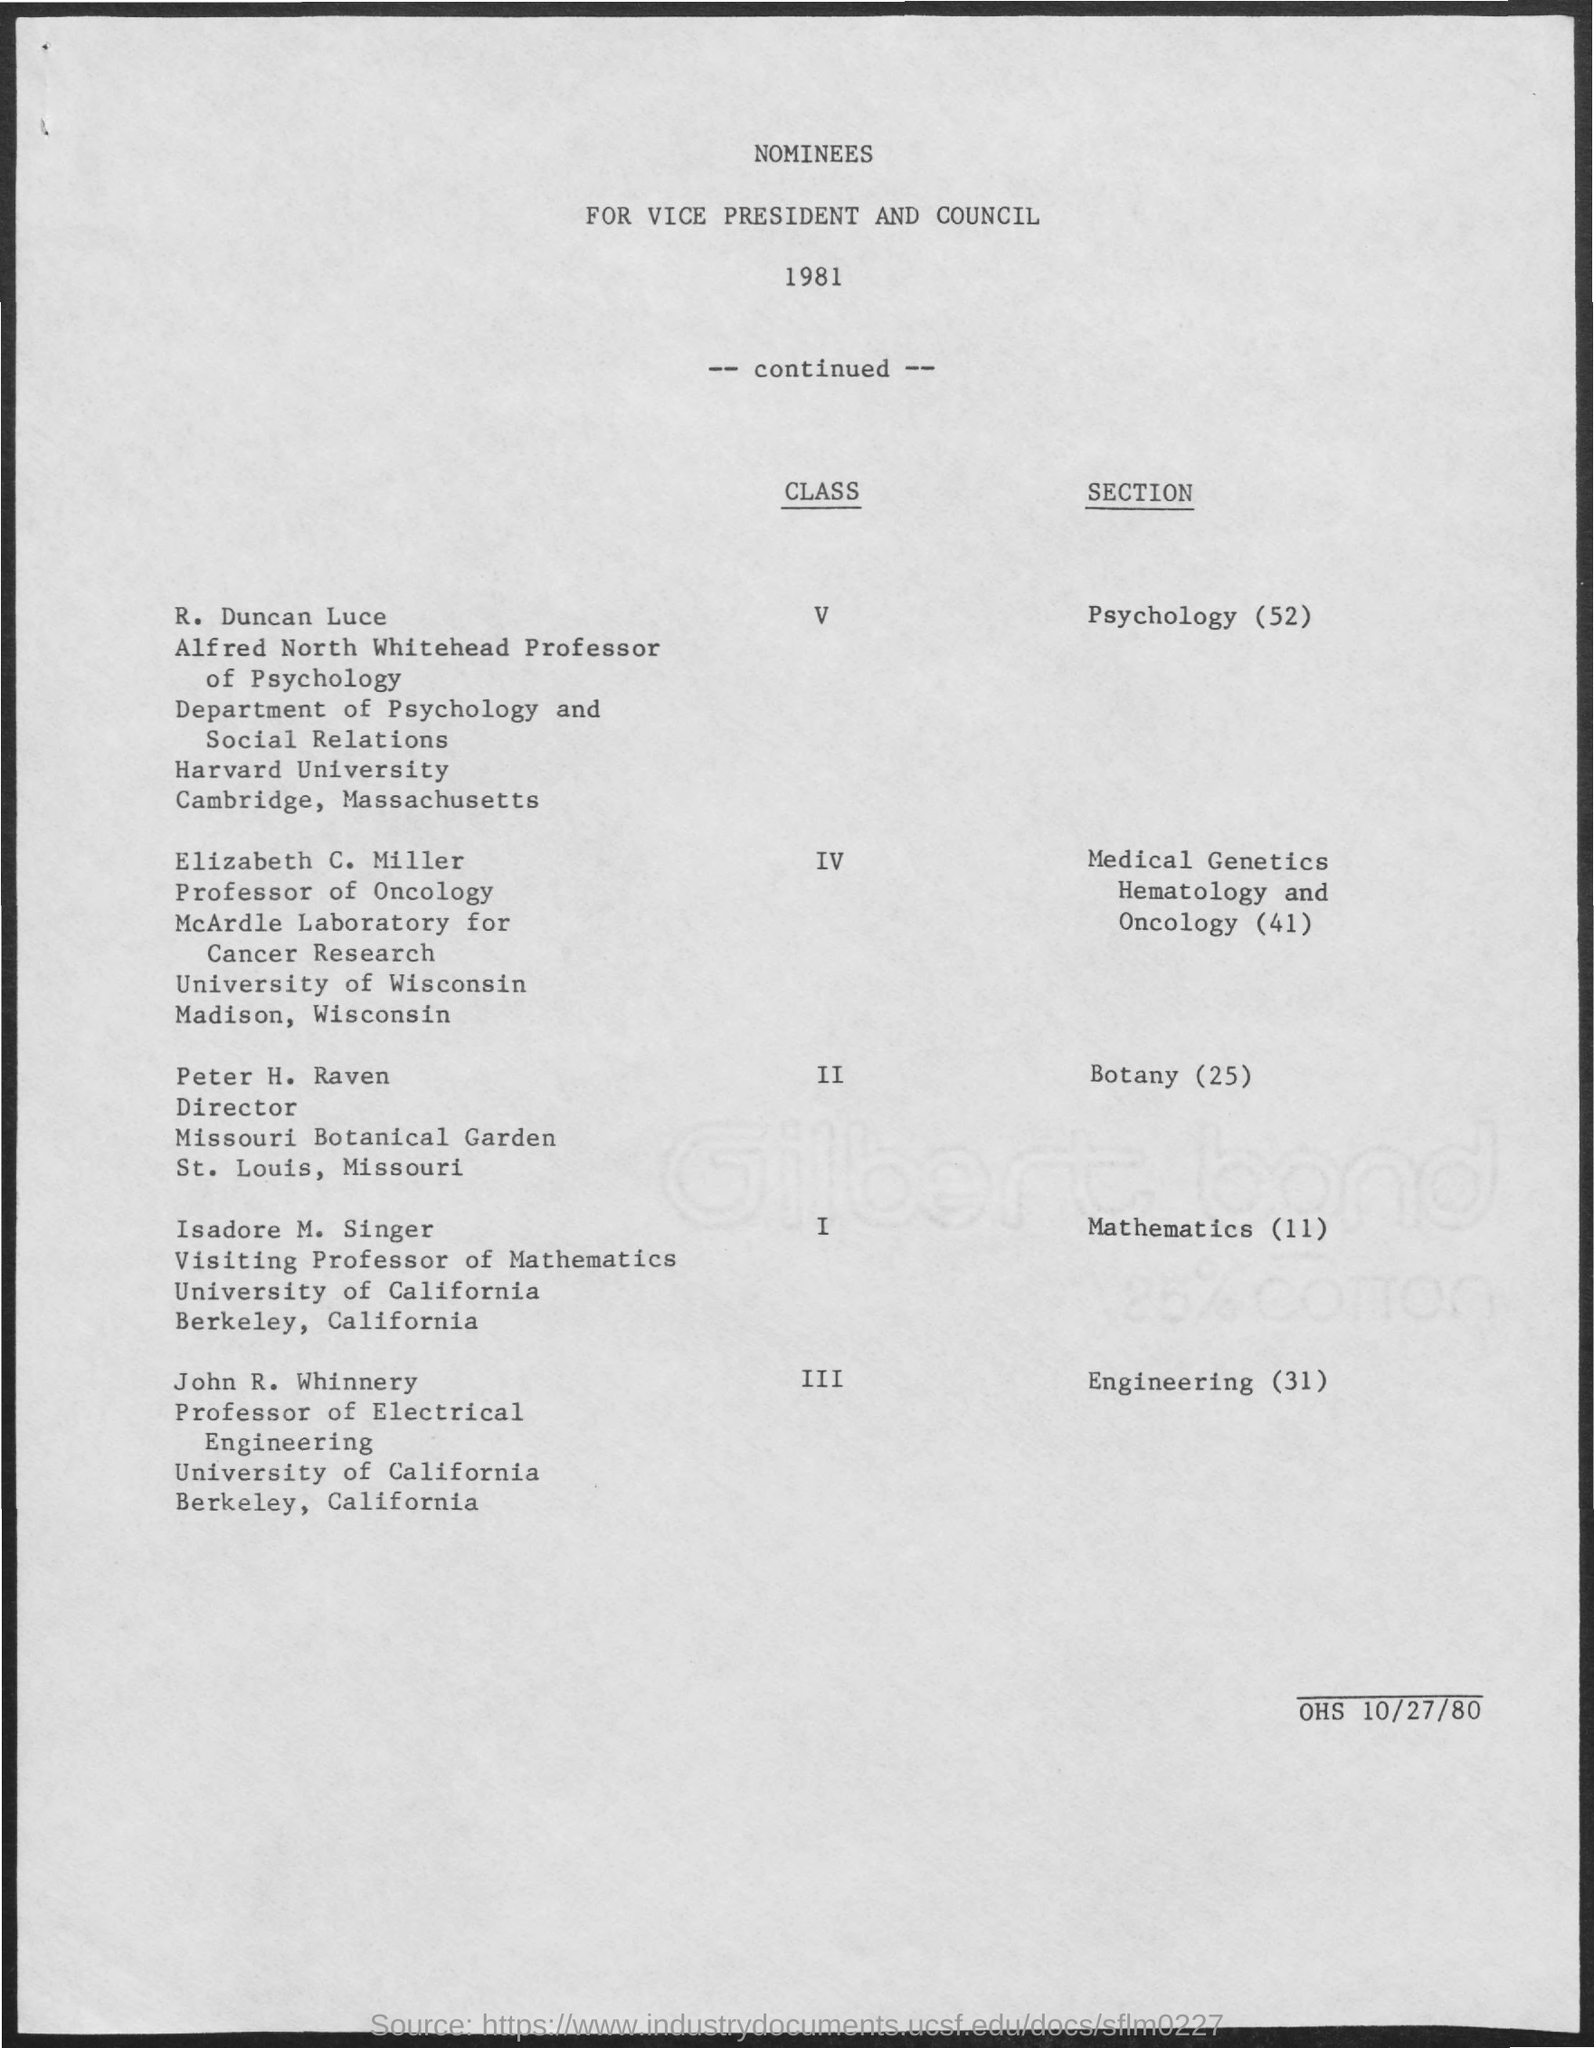Highlight a few significant elements in this photo. Peter H. Raven is in section 25 of the Botany department. Isadore M. Singer is in the section of Mathematics (11). R. Duncan Luce is located in the Psychology section, as indicated by the number 52. Isadore M. Singer is a member of the class. Elizabeth C. Miller is included in the section of Medical Genetics, Hematology and Oncology, as indicated in the given text. 